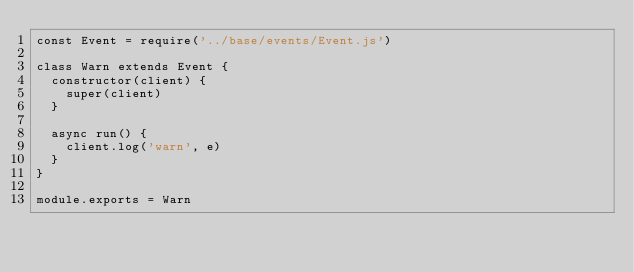<code> <loc_0><loc_0><loc_500><loc_500><_JavaScript_>const Event = require('../base/events/Event.js')

class Warn extends Event {
  constructor(client) {
    super(client)
  }

  async run() {
    client.log('warn', e)
  }
}

module.exports = Warn
</code> 